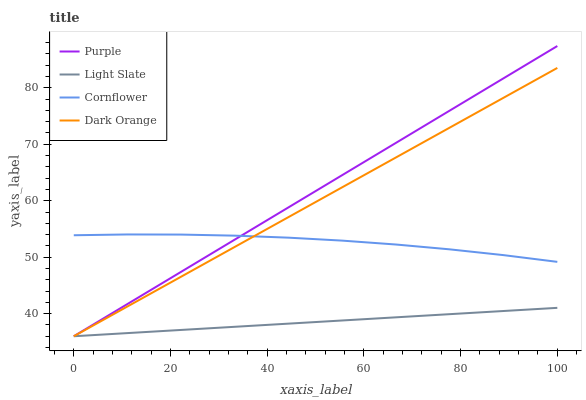Does Light Slate have the minimum area under the curve?
Answer yes or no. Yes. Does Purple have the maximum area under the curve?
Answer yes or no. Yes. Does Dark Orange have the minimum area under the curve?
Answer yes or no. No. Does Dark Orange have the maximum area under the curve?
Answer yes or no. No. Is Dark Orange the smoothest?
Answer yes or no. Yes. Is Cornflower the roughest?
Answer yes or no. Yes. Is Light Slate the smoothest?
Answer yes or no. No. Is Light Slate the roughest?
Answer yes or no. No. Does Purple have the lowest value?
Answer yes or no. Yes. Does Cornflower have the lowest value?
Answer yes or no. No. Does Purple have the highest value?
Answer yes or no. Yes. Does Dark Orange have the highest value?
Answer yes or no. No. Is Light Slate less than Cornflower?
Answer yes or no. Yes. Is Cornflower greater than Light Slate?
Answer yes or no. Yes. Does Light Slate intersect Dark Orange?
Answer yes or no. Yes. Is Light Slate less than Dark Orange?
Answer yes or no. No. Is Light Slate greater than Dark Orange?
Answer yes or no. No. Does Light Slate intersect Cornflower?
Answer yes or no. No. 